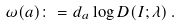<formula> <loc_0><loc_0><loc_500><loc_500>\omega ( a ) \colon = d _ { a } \log D ( I ; \lambda ) \, .</formula> 